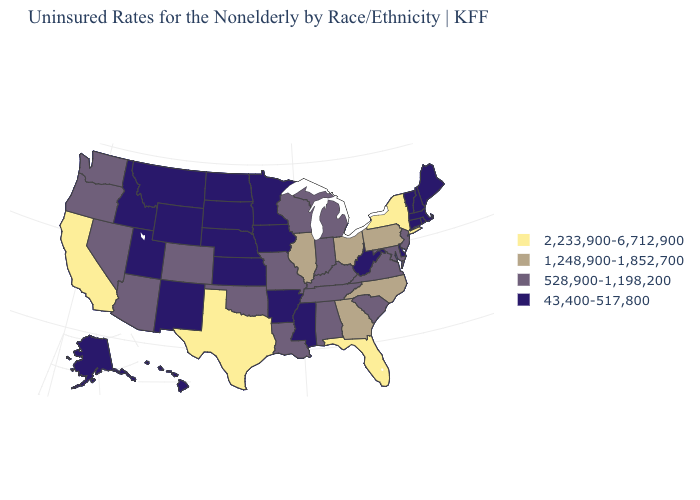Name the states that have a value in the range 43,400-517,800?
Quick response, please. Alaska, Arkansas, Connecticut, Delaware, Hawaii, Idaho, Iowa, Kansas, Maine, Massachusetts, Minnesota, Mississippi, Montana, Nebraska, New Hampshire, New Mexico, North Dakota, Rhode Island, South Dakota, Utah, Vermont, West Virginia, Wyoming. Name the states that have a value in the range 2,233,900-6,712,900?
Be succinct. California, Florida, New York, Texas. What is the value of Minnesota?
Quick response, please. 43,400-517,800. What is the highest value in the MidWest ?
Be succinct. 1,248,900-1,852,700. Does South Dakota have the same value as New York?
Concise answer only. No. Name the states that have a value in the range 43,400-517,800?
Write a very short answer. Alaska, Arkansas, Connecticut, Delaware, Hawaii, Idaho, Iowa, Kansas, Maine, Massachusetts, Minnesota, Mississippi, Montana, Nebraska, New Hampshire, New Mexico, North Dakota, Rhode Island, South Dakota, Utah, Vermont, West Virginia, Wyoming. Does the map have missing data?
Give a very brief answer. No. Does Washington have the same value as Nevada?
Answer briefly. Yes. What is the highest value in the Northeast ?
Keep it brief. 2,233,900-6,712,900. Name the states that have a value in the range 528,900-1,198,200?
Write a very short answer. Alabama, Arizona, Colorado, Indiana, Kentucky, Louisiana, Maryland, Michigan, Missouri, Nevada, New Jersey, Oklahoma, Oregon, South Carolina, Tennessee, Virginia, Washington, Wisconsin. How many symbols are there in the legend?
Give a very brief answer. 4. What is the value of Tennessee?
Concise answer only. 528,900-1,198,200. Which states have the lowest value in the South?
Write a very short answer. Arkansas, Delaware, Mississippi, West Virginia. Which states have the lowest value in the USA?
Keep it brief. Alaska, Arkansas, Connecticut, Delaware, Hawaii, Idaho, Iowa, Kansas, Maine, Massachusetts, Minnesota, Mississippi, Montana, Nebraska, New Hampshire, New Mexico, North Dakota, Rhode Island, South Dakota, Utah, Vermont, West Virginia, Wyoming. Name the states that have a value in the range 528,900-1,198,200?
Quick response, please. Alabama, Arizona, Colorado, Indiana, Kentucky, Louisiana, Maryland, Michigan, Missouri, Nevada, New Jersey, Oklahoma, Oregon, South Carolina, Tennessee, Virginia, Washington, Wisconsin. 